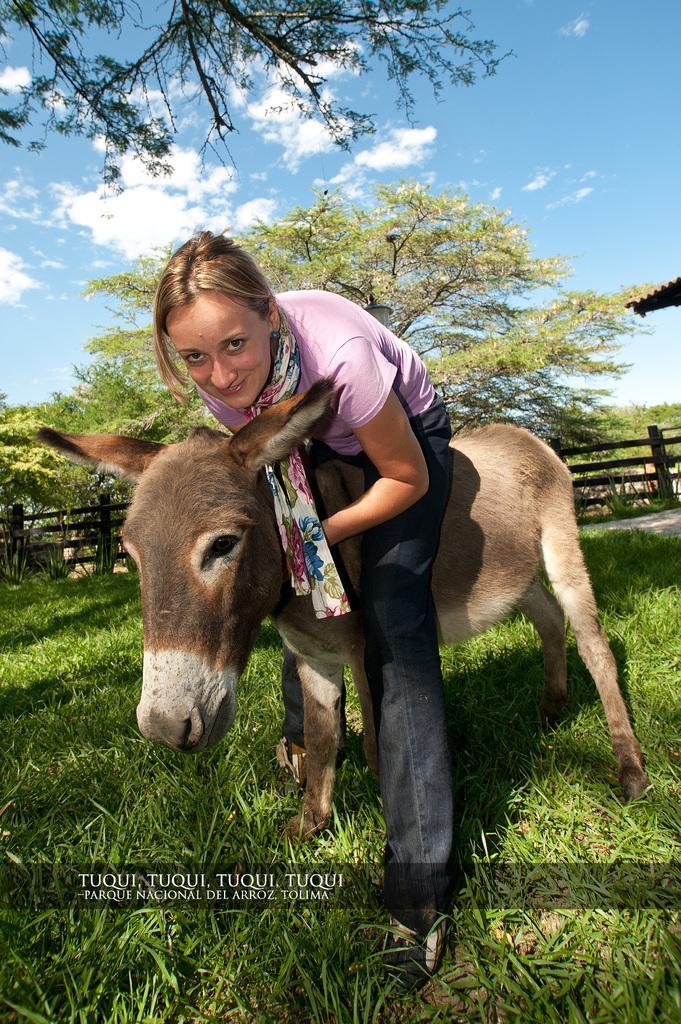In one or two sentences, can you explain what this image depicts? In the picture I can see a person wearing pink color T-shirt, scarf and black color pant is sitting on the donkey. Here I can see the grass, I can see the fence, trees and the blue color sky with clouds in the background. Here I can see the watermark at the bottom of the image. 